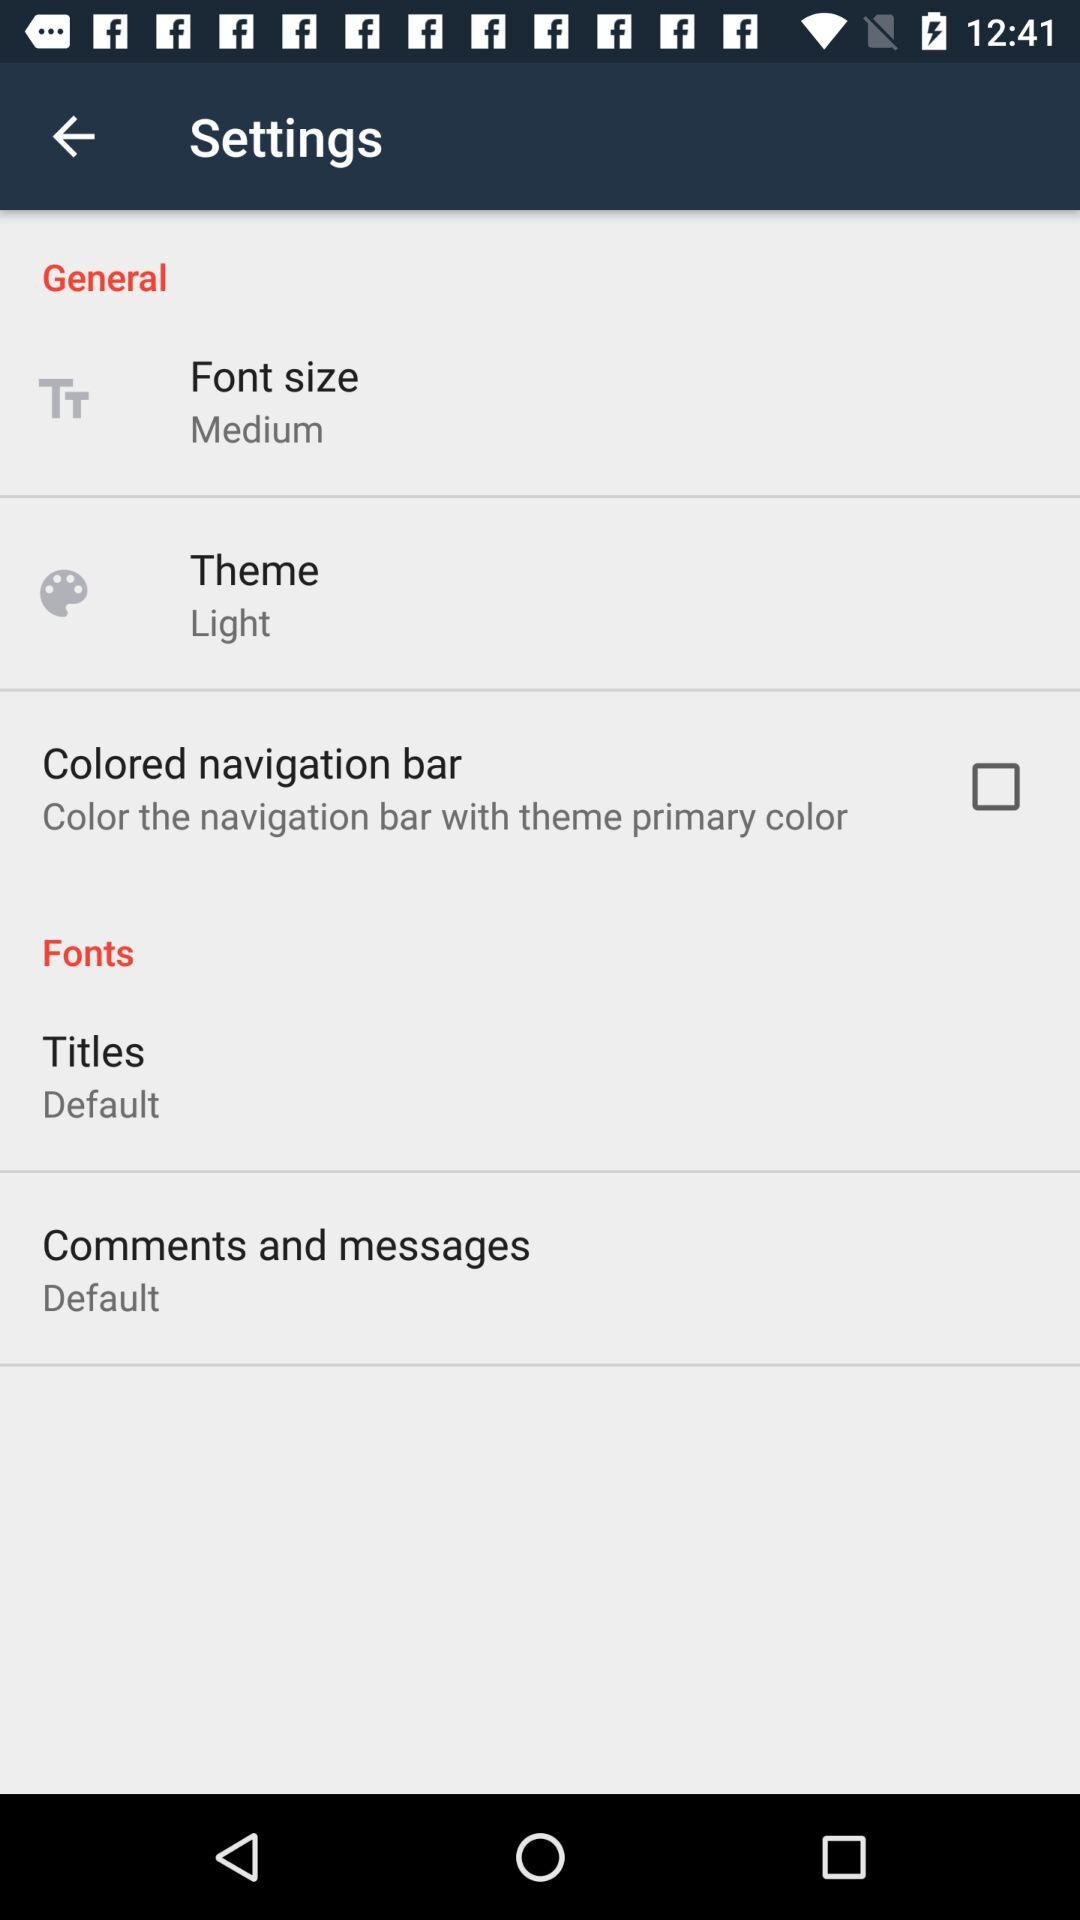What is the font size? The font size is medium. 